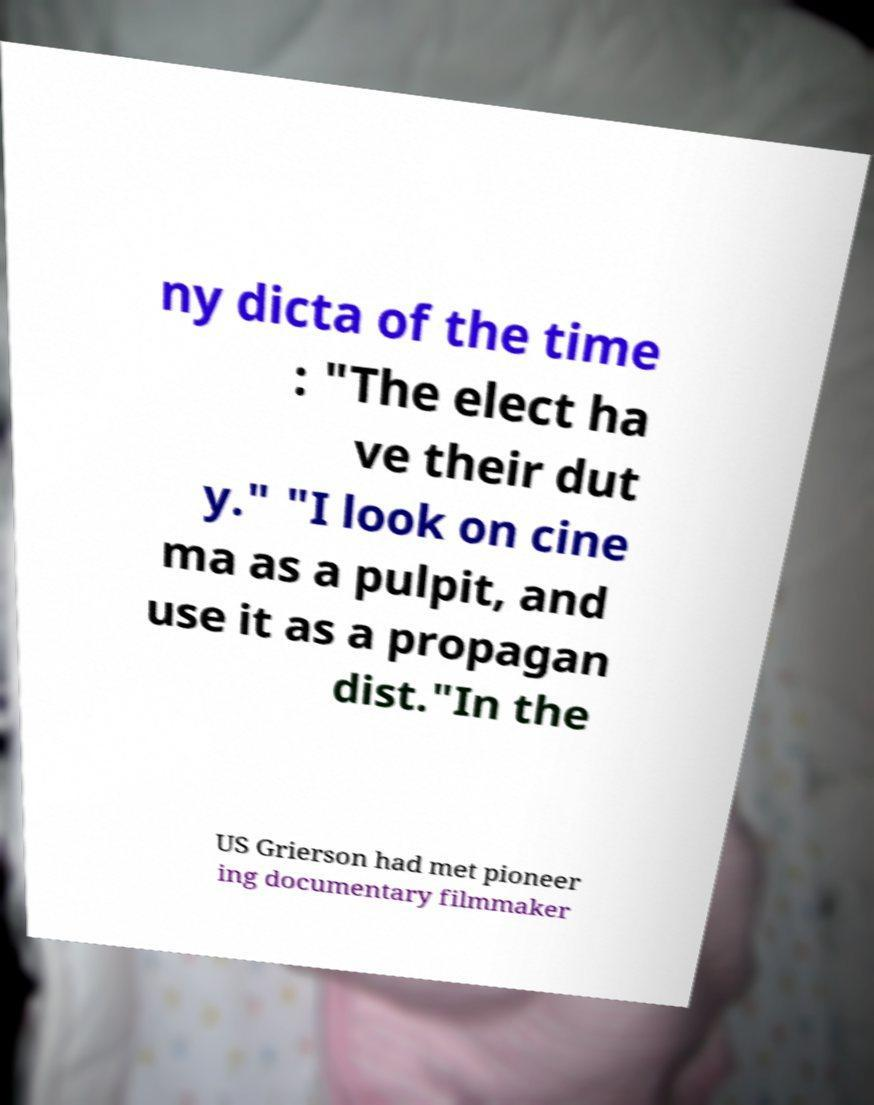For documentation purposes, I need the text within this image transcribed. Could you provide that? ny dicta of the time : "The elect ha ve their dut y." "I look on cine ma as a pulpit, and use it as a propagan dist."In the US Grierson had met pioneer ing documentary filmmaker 